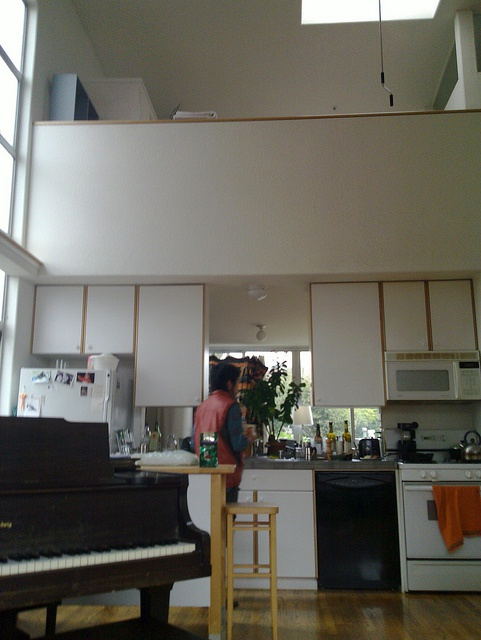Describe the objects in this image and their specific colors. I can see oven in white, gray, maroon, black, and darkgreen tones, refrigerator in white, darkgray, gray, and lightgray tones, microwave in white, gray, darkgreen, and black tones, people in white, black, maroon, brown, and gray tones, and dining table in white, olive, and gray tones in this image. 